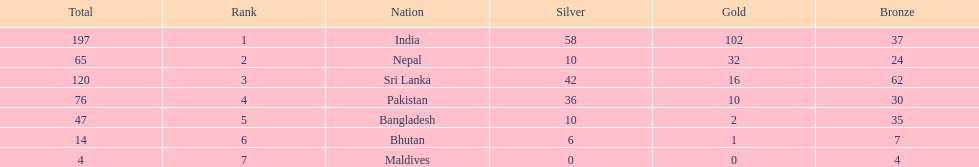What were the total amount won of medals by nations in the 1999 south asian games? 197, 65, 120, 76, 47, 14, 4. Which amount was the lowest? 4. Can you parse all the data within this table? {'header': ['Total', 'Rank', 'Nation', 'Silver', 'Gold', 'Bronze'], 'rows': [['197', '1', 'India', '58', '102', '37'], ['65', '2', 'Nepal', '10', '32', '24'], ['120', '3', 'Sri Lanka', '42', '16', '62'], ['76', '4', 'Pakistan', '36', '10', '30'], ['47', '5', 'Bangladesh', '10', '2', '35'], ['14', '6', 'Bhutan', '6', '1', '7'], ['4', '7', 'Maldives', '0', '0', '4']]} Which nation had this amount? Maldives. 